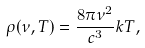Convert formula to latex. <formula><loc_0><loc_0><loc_500><loc_500>\rho ( \nu , T ) = \frac { 8 \pi \nu ^ { 2 } } { c ^ { 3 } } k T ,</formula> 